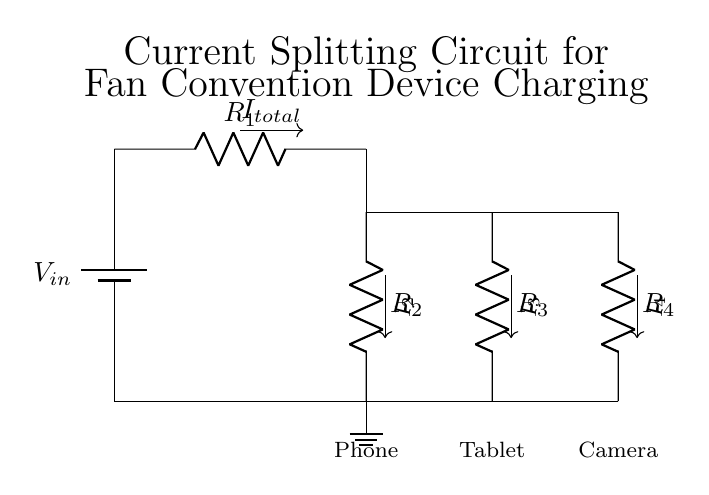what is the input voltage of the circuit? The input voltage, denoted as V_in in the diagram, is the voltage supplied by the battery at the top of the circuit.
Answer: V_in how many resistors are used in the circuit? The circuit contains four resistors indicated by R_1, R_2, R_3, and R_4.
Answer: 4 which device has the lowest current? By analyzing the resistors, the device that is connected to the highest resistance (R_4) will have the lowest current due to Ohm's Law. Therefore, the camera will receive the least current.
Answer: Camera what is the total current in the circuit? Total current, denoted as I_total, is the current from the battery flowing into the circuit before it splits. The exact value isn't provided in the diagram, but this is typically calculated at the power supply.
Answer: I_total how does the current split among the devices? The current division principle states that the current splits inversely to the resistance; lower resistance carries more current, while higher resistance carries less. The ratio of current distribution is determined by the resistors' values.
Answer: Inversely to resistance which device is connected to the middle branch of the circuit? The middle branch in the current divider is connected to the second resistor R_3, which corresponds to the tablet in the diagram.
Answer: Tablet 